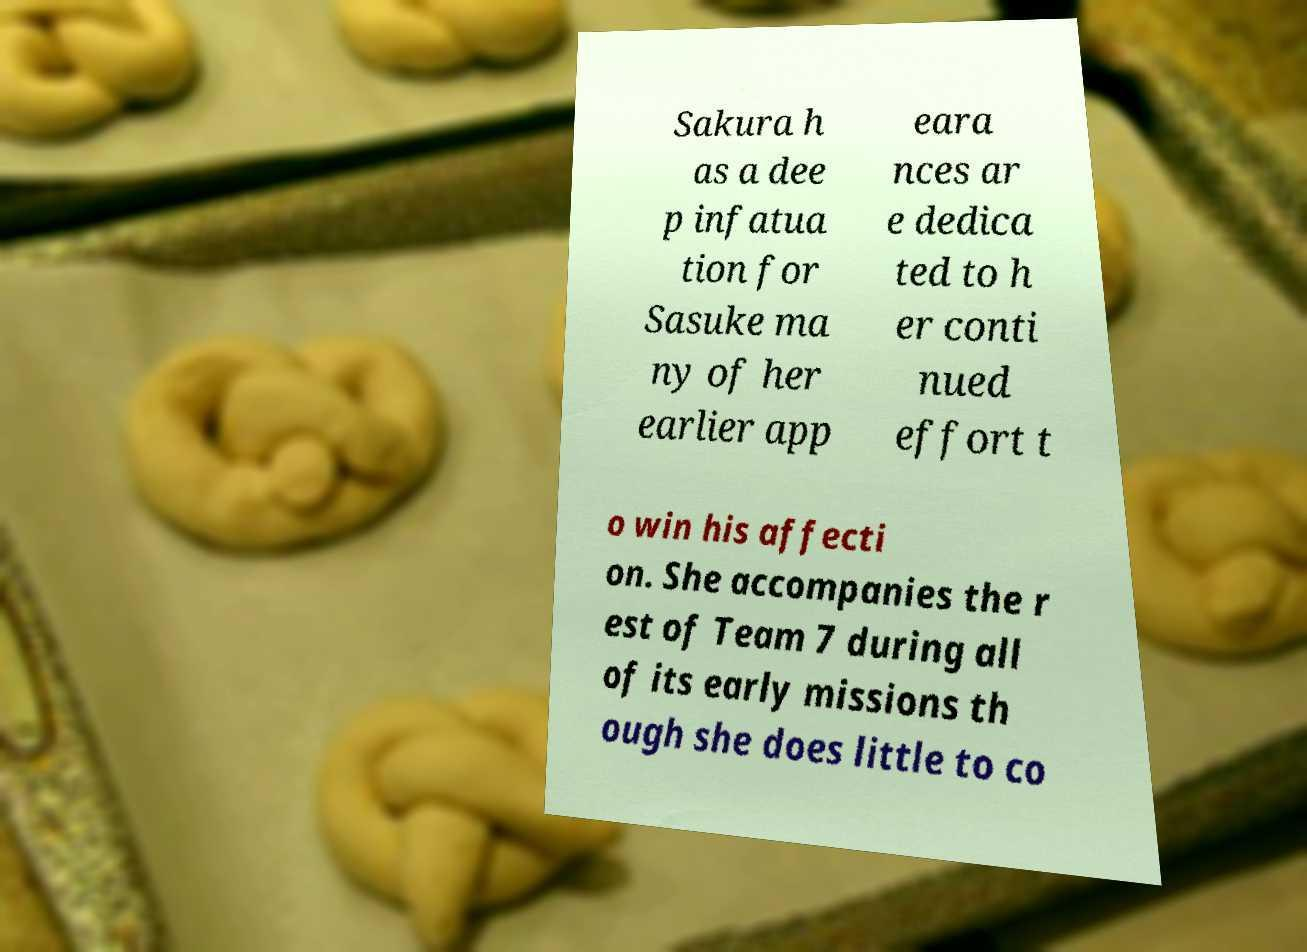Please identify and transcribe the text found in this image. Sakura h as a dee p infatua tion for Sasuke ma ny of her earlier app eara nces ar e dedica ted to h er conti nued effort t o win his affecti on. She accompanies the r est of Team 7 during all of its early missions th ough she does little to co 